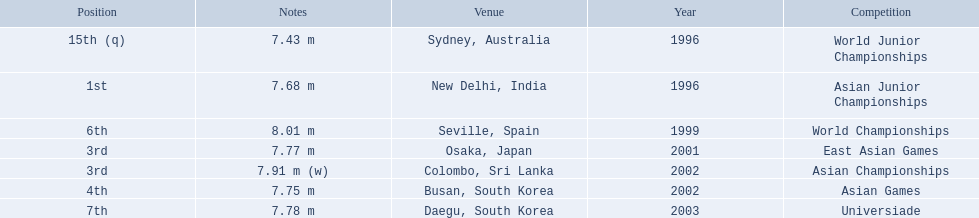What are all of the competitions? World Junior Championships, Asian Junior Championships, World Championships, East Asian Games, Asian Championships, Asian Games, Universiade. What was his positions in these competitions? 15th (q), 1st, 6th, 3rd, 3rd, 4th, 7th. And during which competition did he reach 1st place? Asian Junior Championships. 